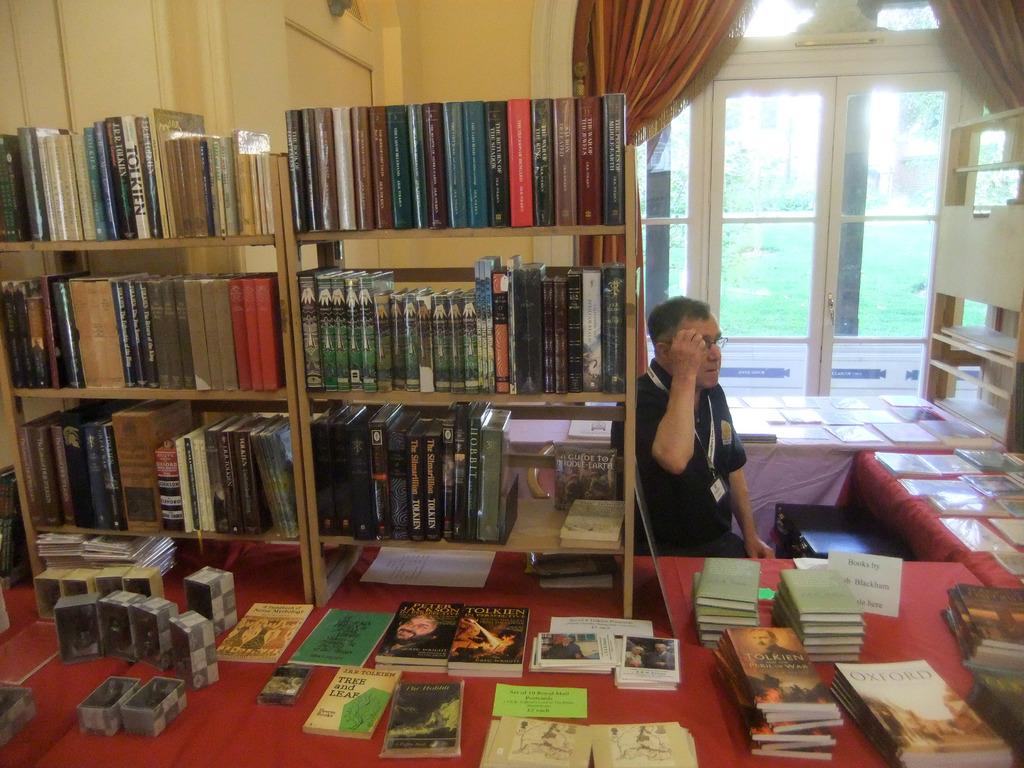What is the name of the book on the left in the first row?
Make the answer very short. Unanswerable. 